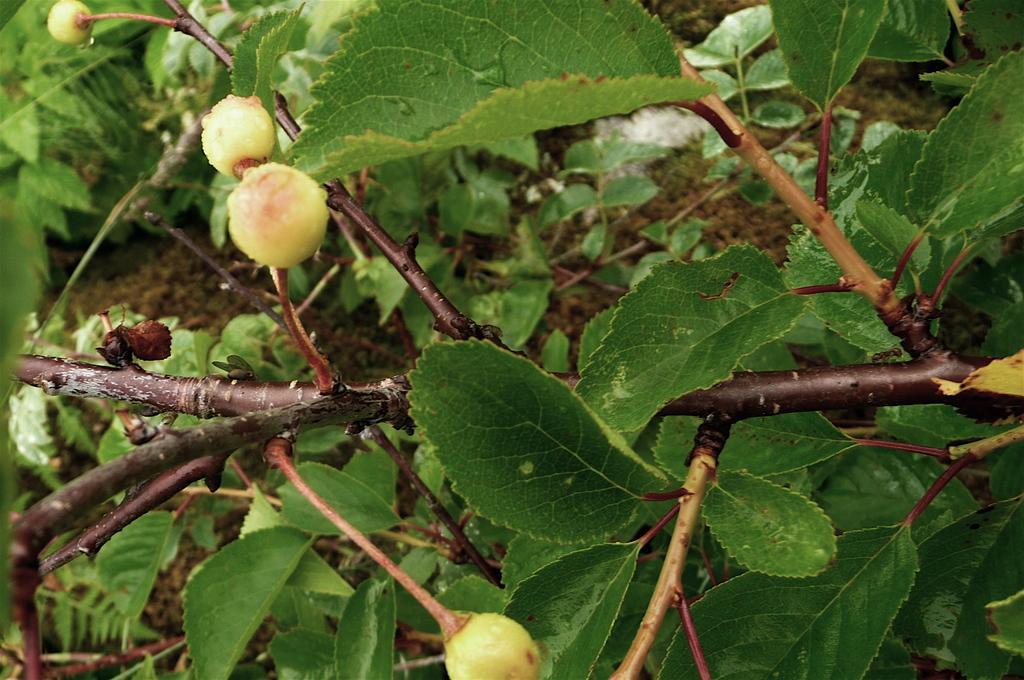In one or two sentences, can you explain what this image depicts? In this image I can see some fruits and green color leaves to a stem. At the bottom I can see the mud. 